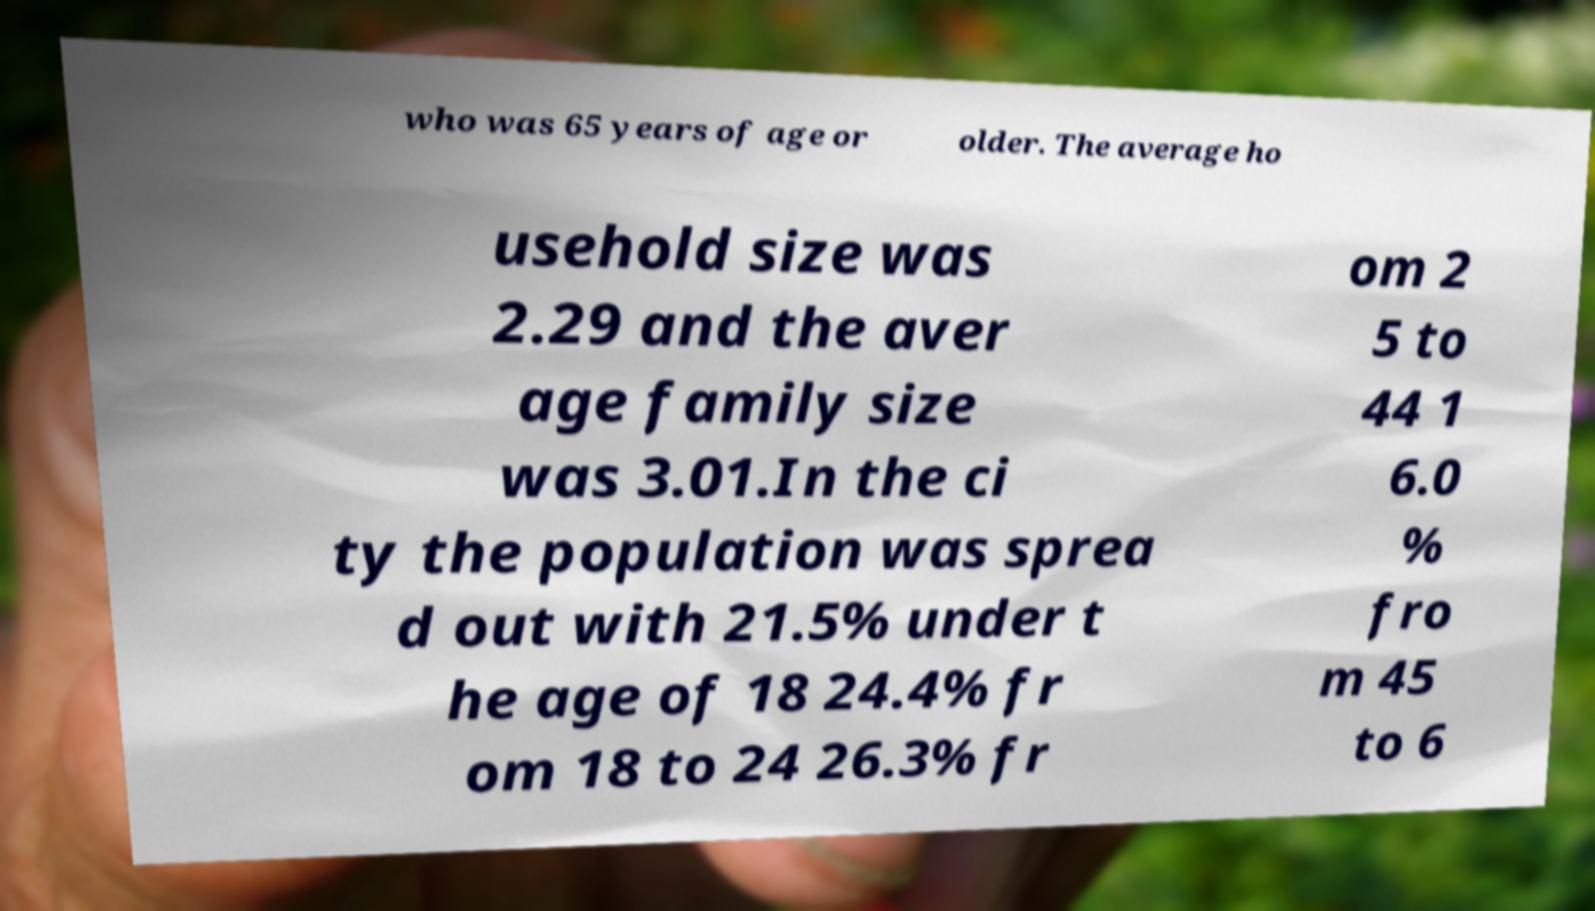I need the written content from this picture converted into text. Can you do that? who was 65 years of age or older. The average ho usehold size was 2.29 and the aver age family size was 3.01.In the ci ty the population was sprea d out with 21.5% under t he age of 18 24.4% fr om 18 to 24 26.3% fr om 2 5 to 44 1 6.0 % fro m 45 to 6 